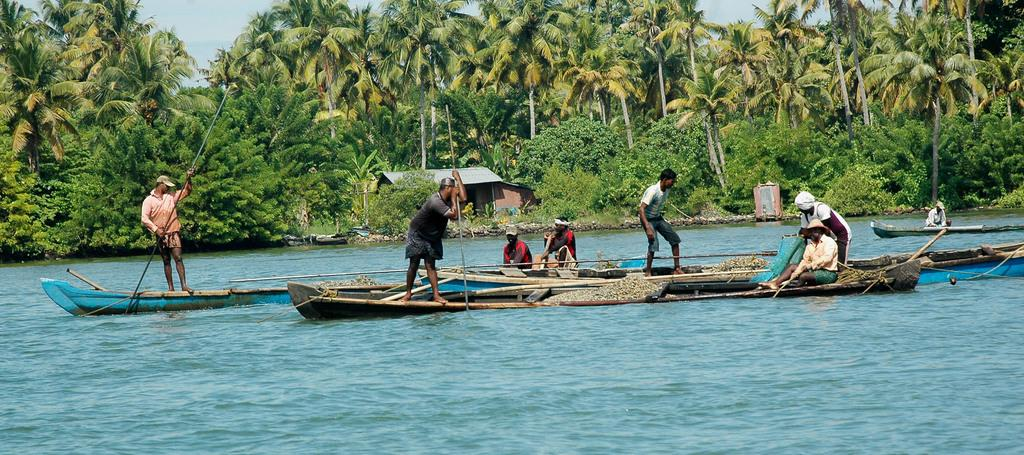What are the people in the image doing? The people in the image are on a boat. What can be seen in the background of the image? There are trees and a house in the background of the image. What is the primary setting of the image? The primary setting of the image is water, as the boat is on the water. What type of cheese is being used to rake the leaves in the image? There is no cheese or rake present in the image. The people are on a boat, and there are trees and a house in the background. 